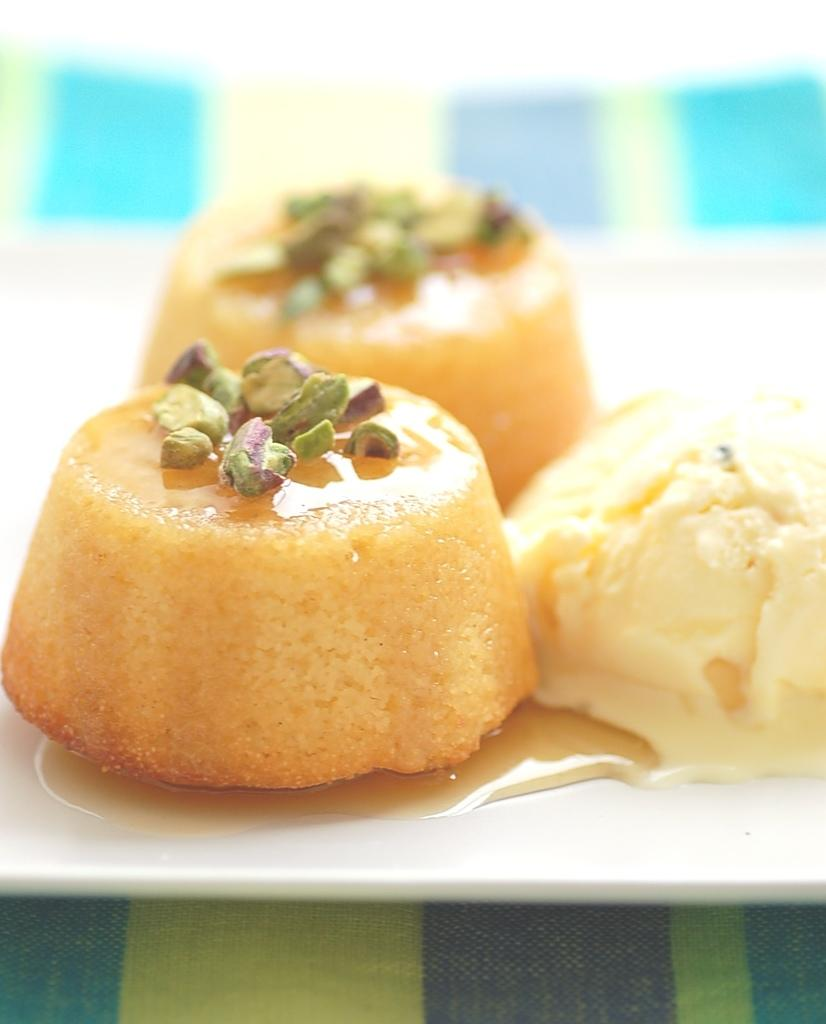What is on the plate in the image? There are food items on the plate in the image. Can you describe anything else visible at the bottom of the image? Yes, there is cloth visible at the bottom of the image. What type of crime is being committed in the image? There is no indication of any crime being committed in the image. Can you describe the hammer used to break the plate in the image? There is no hammer or plate breaking in the image; it only shows food items on a plate and cloth at the bottom. 